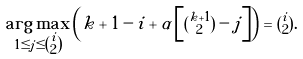Convert formula to latex. <formula><loc_0><loc_0><loc_500><loc_500>\underset { 1 \leq j \leq \tbinom { i } { 2 } } { \arg \max } \left ( k + 1 - i + \alpha \left [ \tbinom { k + 1 } { 2 } - j \right ] \right ) = \tbinom { i } { 2 } .</formula> 